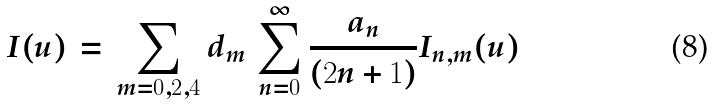Convert formula to latex. <formula><loc_0><loc_0><loc_500><loc_500>I ( u ) \, = \, \sum _ { m = 0 , 2 , 4 } d _ { m } \, \sum _ { n = 0 } ^ { \infty } \frac { a _ { n } } { ( 2 n + 1 ) } I _ { n , m } ( u )</formula> 